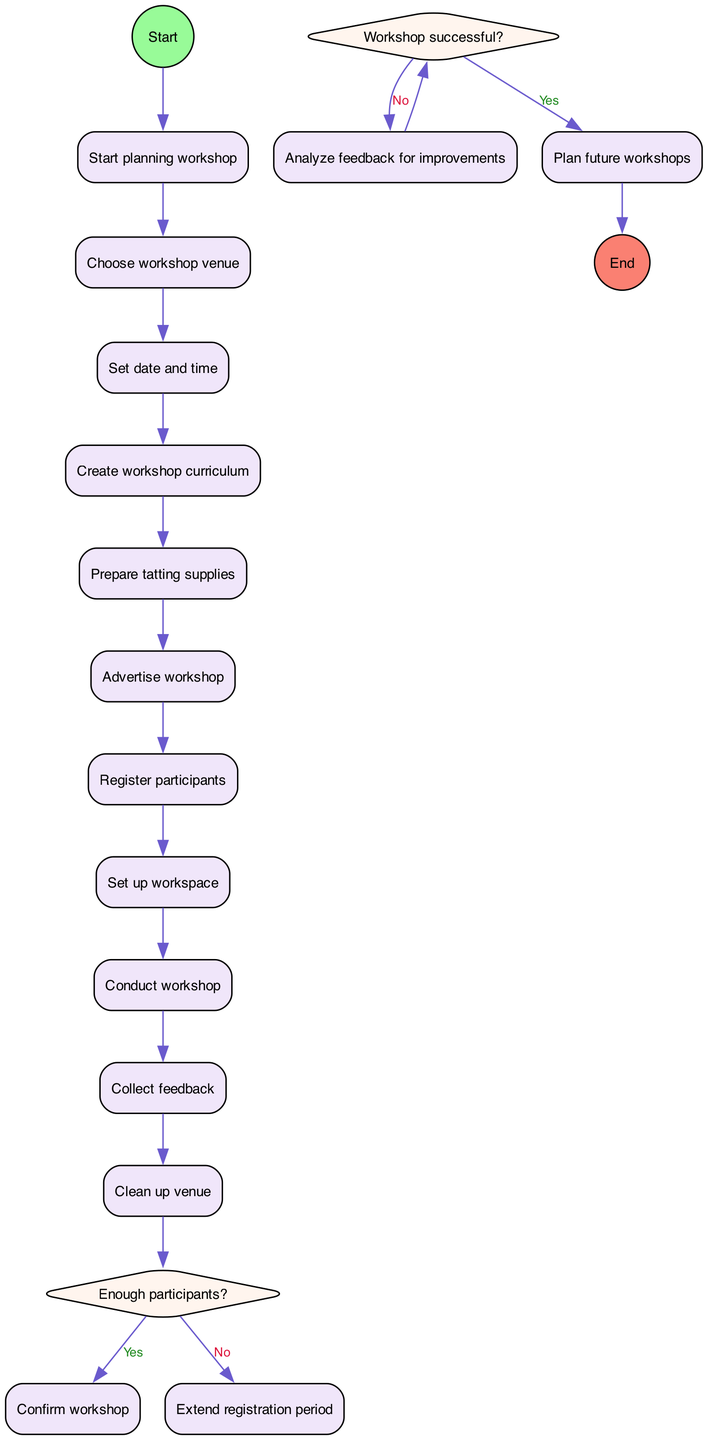What is the first activity in the diagram? The diagram starts with the initial node labeled "Start planning workshop", which leads directly to the first activity labeled "Choose workshop venue".
Answer: Choose workshop venue How many activities are in the diagram? By counting each activity node listed in the diagram, we find there are ten individual activities, from "Choose workshop venue" to "Clean up venue".
Answer: 10 What is the final node in the diagram? The diagram concludes with the final node labeled "End workshop process" which is the last part of the workflow.
Answer: End workshop process What do you do if there are not enough participants? According to the decision node in the diagram, if there are not enough participants, the workflow directs to "Extend registration period" before confirming the workshop.
Answer: Extend registration period What activity follows "Conduct workshop"? After "Conduct workshop", the next activity indicated in the flow of the diagram is "Collect feedback".
Answer: Collect feedback How many decision points are represented in the diagram? The diagram shows two decision points, which are based on the questions "Enough participants?" and "Workshop successful?".
Answer: 2 What is the outcome if the workshop is successful? If the "Workshop successful?" decision is answered with "Yes", the diagram indicates the result is to "Plan future workshops".
Answer: Plan future workshops What is the relationship between "Prepare tatting supplies" and "Advertise workshop"? The relationship is that "Prepare tatting supplies" leads directly to "Advertise workshop" in the sequence of activities, indicating it must be completed before advertising.
Answer: Sequential activity Where does "Clean up venue" fit in the overall process? "Clean up venue" is the last activity performed before reaching the final node, thus it fits in as the concluding task of the overall workshop process.
Answer: Last activity 